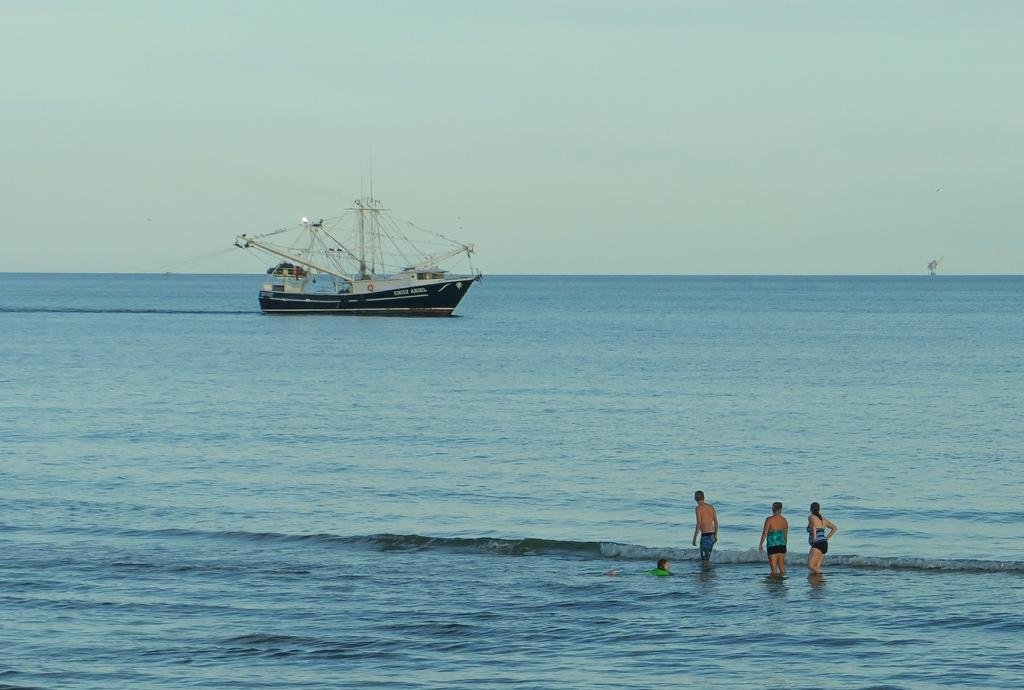What is in the water in the image? There is a boat in the water in the image. What can be seen near the water? There are people standing near the water. What activity is a person engaged in the water? A human is swimming in the water. How would you describe the sky in the image? The sky is cloudy in the image. Can you tell me how many branches are hanging over the water in the image? There are no branches visible in the image; it features a boat, people, and a swimmer in the water. What type of giants can be seen walking near the water in the image? There are no giants present in the image; it features a boat, people, and a swimmer in the water. 